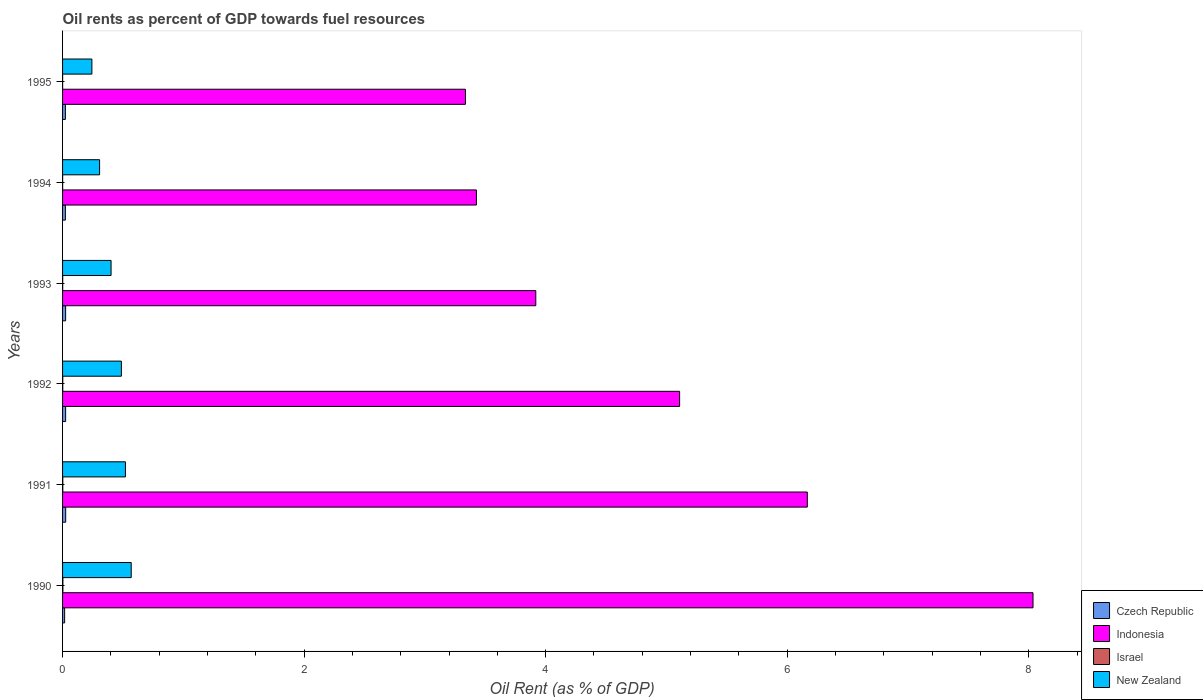How many different coloured bars are there?
Make the answer very short. 4. How many groups of bars are there?
Offer a terse response. 6. Are the number of bars on each tick of the Y-axis equal?
Give a very brief answer. Yes. How many bars are there on the 1st tick from the top?
Ensure brevity in your answer.  4. In how many cases, is the number of bars for a given year not equal to the number of legend labels?
Your response must be concise. 0. What is the oil rent in Czech Republic in 1992?
Offer a terse response. 0.03. Across all years, what is the maximum oil rent in New Zealand?
Offer a very short reply. 0.57. Across all years, what is the minimum oil rent in Indonesia?
Ensure brevity in your answer.  3.34. What is the total oil rent in Czech Republic in the graph?
Your response must be concise. 0.14. What is the difference between the oil rent in New Zealand in 1993 and that in 1994?
Provide a succinct answer. 0.1. What is the difference between the oil rent in Czech Republic in 1994 and the oil rent in Indonesia in 1991?
Your response must be concise. -6.14. What is the average oil rent in Czech Republic per year?
Offer a terse response. 0.02. In the year 1991, what is the difference between the oil rent in New Zealand and oil rent in Czech Republic?
Give a very brief answer. 0.49. What is the ratio of the oil rent in New Zealand in 1994 to that in 1995?
Offer a terse response. 1.26. Is the difference between the oil rent in New Zealand in 1992 and 1995 greater than the difference between the oil rent in Czech Republic in 1992 and 1995?
Keep it short and to the point. Yes. What is the difference between the highest and the second highest oil rent in New Zealand?
Offer a terse response. 0.05. What is the difference between the highest and the lowest oil rent in New Zealand?
Make the answer very short. 0.33. In how many years, is the oil rent in Indonesia greater than the average oil rent in Indonesia taken over all years?
Your answer should be compact. 3. Is it the case that in every year, the sum of the oil rent in New Zealand and oil rent in Czech Republic is greater than the sum of oil rent in Indonesia and oil rent in Israel?
Your response must be concise. Yes. What does the 4th bar from the top in 1994 represents?
Offer a terse response. Czech Republic. What does the 2nd bar from the bottom in 1995 represents?
Ensure brevity in your answer.  Indonesia. Is it the case that in every year, the sum of the oil rent in New Zealand and oil rent in Indonesia is greater than the oil rent in Czech Republic?
Your response must be concise. Yes. Are all the bars in the graph horizontal?
Offer a very short reply. Yes. How many years are there in the graph?
Ensure brevity in your answer.  6. What is the difference between two consecutive major ticks on the X-axis?
Offer a very short reply. 2. Does the graph contain any zero values?
Offer a very short reply. No. Does the graph contain grids?
Provide a short and direct response. No. Where does the legend appear in the graph?
Offer a terse response. Bottom right. How are the legend labels stacked?
Make the answer very short. Vertical. What is the title of the graph?
Keep it short and to the point. Oil rents as percent of GDP towards fuel resources. Does "Congo (Republic)" appear as one of the legend labels in the graph?
Ensure brevity in your answer.  No. What is the label or title of the X-axis?
Your answer should be compact. Oil Rent (as % of GDP). What is the label or title of the Y-axis?
Offer a very short reply. Years. What is the Oil Rent (as % of GDP) of Czech Republic in 1990?
Your response must be concise. 0.02. What is the Oil Rent (as % of GDP) in Indonesia in 1990?
Keep it short and to the point. 8.04. What is the Oil Rent (as % of GDP) of Israel in 1990?
Provide a short and direct response. 0. What is the Oil Rent (as % of GDP) in New Zealand in 1990?
Offer a terse response. 0.57. What is the Oil Rent (as % of GDP) of Czech Republic in 1991?
Your response must be concise. 0.03. What is the Oil Rent (as % of GDP) in Indonesia in 1991?
Give a very brief answer. 6.17. What is the Oil Rent (as % of GDP) in Israel in 1991?
Offer a very short reply. 0. What is the Oil Rent (as % of GDP) of New Zealand in 1991?
Keep it short and to the point. 0.52. What is the Oil Rent (as % of GDP) of Czech Republic in 1992?
Provide a succinct answer. 0.03. What is the Oil Rent (as % of GDP) in Indonesia in 1992?
Offer a very short reply. 5.11. What is the Oil Rent (as % of GDP) of Israel in 1992?
Offer a terse response. 0. What is the Oil Rent (as % of GDP) of New Zealand in 1992?
Provide a short and direct response. 0.49. What is the Oil Rent (as % of GDP) in Czech Republic in 1993?
Make the answer very short. 0.03. What is the Oil Rent (as % of GDP) of Indonesia in 1993?
Your answer should be compact. 3.92. What is the Oil Rent (as % of GDP) of Israel in 1993?
Provide a short and direct response. 0. What is the Oil Rent (as % of GDP) in New Zealand in 1993?
Give a very brief answer. 0.4. What is the Oil Rent (as % of GDP) in Czech Republic in 1994?
Make the answer very short. 0.02. What is the Oil Rent (as % of GDP) of Indonesia in 1994?
Make the answer very short. 3.43. What is the Oil Rent (as % of GDP) of Israel in 1994?
Offer a terse response. 0. What is the Oil Rent (as % of GDP) in New Zealand in 1994?
Offer a terse response. 0.31. What is the Oil Rent (as % of GDP) of Czech Republic in 1995?
Keep it short and to the point. 0.02. What is the Oil Rent (as % of GDP) in Indonesia in 1995?
Your response must be concise. 3.34. What is the Oil Rent (as % of GDP) in Israel in 1995?
Your answer should be compact. 0. What is the Oil Rent (as % of GDP) in New Zealand in 1995?
Your response must be concise. 0.24. Across all years, what is the maximum Oil Rent (as % of GDP) of Czech Republic?
Provide a short and direct response. 0.03. Across all years, what is the maximum Oil Rent (as % of GDP) of Indonesia?
Make the answer very short. 8.04. Across all years, what is the maximum Oil Rent (as % of GDP) in Israel?
Keep it short and to the point. 0. Across all years, what is the maximum Oil Rent (as % of GDP) of New Zealand?
Your answer should be compact. 0.57. Across all years, what is the minimum Oil Rent (as % of GDP) of Czech Republic?
Your answer should be compact. 0.02. Across all years, what is the minimum Oil Rent (as % of GDP) of Indonesia?
Your response must be concise. 3.34. Across all years, what is the minimum Oil Rent (as % of GDP) in Israel?
Your answer should be very brief. 0. Across all years, what is the minimum Oil Rent (as % of GDP) of New Zealand?
Ensure brevity in your answer.  0.24. What is the total Oil Rent (as % of GDP) in Czech Republic in the graph?
Your answer should be very brief. 0.14. What is the total Oil Rent (as % of GDP) of Indonesia in the graph?
Make the answer very short. 29.99. What is the total Oil Rent (as % of GDP) of Israel in the graph?
Give a very brief answer. 0.01. What is the total Oil Rent (as % of GDP) in New Zealand in the graph?
Provide a succinct answer. 2.53. What is the difference between the Oil Rent (as % of GDP) of Czech Republic in 1990 and that in 1991?
Your answer should be very brief. -0.01. What is the difference between the Oil Rent (as % of GDP) of Indonesia in 1990 and that in 1991?
Your answer should be very brief. 1.87. What is the difference between the Oil Rent (as % of GDP) in Israel in 1990 and that in 1991?
Keep it short and to the point. 0. What is the difference between the Oil Rent (as % of GDP) in New Zealand in 1990 and that in 1991?
Give a very brief answer. 0.05. What is the difference between the Oil Rent (as % of GDP) of Czech Republic in 1990 and that in 1992?
Provide a short and direct response. -0.01. What is the difference between the Oil Rent (as % of GDP) of Indonesia in 1990 and that in 1992?
Ensure brevity in your answer.  2.93. What is the difference between the Oil Rent (as % of GDP) of Israel in 1990 and that in 1992?
Provide a short and direct response. 0. What is the difference between the Oil Rent (as % of GDP) in New Zealand in 1990 and that in 1992?
Your response must be concise. 0.08. What is the difference between the Oil Rent (as % of GDP) of Czech Republic in 1990 and that in 1993?
Your response must be concise. -0.01. What is the difference between the Oil Rent (as % of GDP) in Indonesia in 1990 and that in 1993?
Offer a terse response. 4.12. What is the difference between the Oil Rent (as % of GDP) of Israel in 1990 and that in 1993?
Offer a terse response. 0. What is the difference between the Oil Rent (as % of GDP) of New Zealand in 1990 and that in 1993?
Ensure brevity in your answer.  0.17. What is the difference between the Oil Rent (as % of GDP) of Czech Republic in 1990 and that in 1994?
Provide a short and direct response. -0.01. What is the difference between the Oil Rent (as % of GDP) in Indonesia in 1990 and that in 1994?
Offer a very short reply. 4.61. What is the difference between the Oil Rent (as % of GDP) of Israel in 1990 and that in 1994?
Give a very brief answer. 0. What is the difference between the Oil Rent (as % of GDP) of New Zealand in 1990 and that in 1994?
Provide a short and direct response. 0.26. What is the difference between the Oil Rent (as % of GDP) in Czech Republic in 1990 and that in 1995?
Make the answer very short. -0.01. What is the difference between the Oil Rent (as % of GDP) in Indonesia in 1990 and that in 1995?
Make the answer very short. 4.7. What is the difference between the Oil Rent (as % of GDP) of Israel in 1990 and that in 1995?
Offer a terse response. 0. What is the difference between the Oil Rent (as % of GDP) of New Zealand in 1990 and that in 1995?
Make the answer very short. 0.33. What is the difference between the Oil Rent (as % of GDP) in Indonesia in 1991 and that in 1992?
Your response must be concise. 1.06. What is the difference between the Oil Rent (as % of GDP) of New Zealand in 1991 and that in 1992?
Provide a succinct answer. 0.03. What is the difference between the Oil Rent (as % of GDP) in Indonesia in 1991 and that in 1993?
Make the answer very short. 2.25. What is the difference between the Oil Rent (as % of GDP) in Israel in 1991 and that in 1993?
Give a very brief answer. 0. What is the difference between the Oil Rent (as % of GDP) of New Zealand in 1991 and that in 1993?
Keep it short and to the point. 0.12. What is the difference between the Oil Rent (as % of GDP) of Czech Republic in 1991 and that in 1994?
Make the answer very short. 0. What is the difference between the Oil Rent (as % of GDP) in Indonesia in 1991 and that in 1994?
Your answer should be compact. 2.74. What is the difference between the Oil Rent (as % of GDP) of Israel in 1991 and that in 1994?
Your answer should be very brief. 0. What is the difference between the Oil Rent (as % of GDP) of New Zealand in 1991 and that in 1994?
Provide a succinct answer. 0.21. What is the difference between the Oil Rent (as % of GDP) in Czech Republic in 1991 and that in 1995?
Your answer should be very brief. 0. What is the difference between the Oil Rent (as % of GDP) of Indonesia in 1991 and that in 1995?
Offer a very short reply. 2.83. What is the difference between the Oil Rent (as % of GDP) of Israel in 1991 and that in 1995?
Offer a terse response. 0. What is the difference between the Oil Rent (as % of GDP) of New Zealand in 1991 and that in 1995?
Give a very brief answer. 0.28. What is the difference between the Oil Rent (as % of GDP) in Czech Republic in 1992 and that in 1993?
Provide a succinct answer. -0. What is the difference between the Oil Rent (as % of GDP) in Indonesia in 1992 and that in 1993?
Ensure brevity in your answer.  1.19. What is the difference between the Oil Rent (as % of GDP) of Israel in 1992 and that in 1993?
Your answer should be very brief. 0. What is the difference between the Oil Rent (as % of GDP) of New Zealand in 1992 and that in 1993?
Offer a terse response. 0.09. What is the difference between the Oil Rent (as % of GDP) in Czech Republic in 1992 and that in 1994?
Your answer should be compact. 0. What is the difference between the Oil Rent (as % of GDP) of Indonesia in 1992 and that in 1994?
Give a very brief answer. 1.68. What is the difference between the Oil Rent (as % of GDP) of New Zealand in 1992 and that in 1994?
Provide a short and direct response. 0.18. What is the difference between the Oil Rent (as % of GDP) of Czech Republic in 1992 and that in 1995?
Ensure brevity in your answer.  0. What is the difference between the Oil Rent (as % of GDP) of Indonesia in 1992 and that in 1995?
Ensure brevity in your answer.  1.77. What is the difference between the Oil Rent (as % of GDP) in Israel in 1992 and that in 1995?
Make the answer very short. 0. What is the difference between the Oil Rent (as % of GDP) in New Zealand in 1992 and that in 1995?
Ensure brevity in your answer.  0.24. What is the difference between the Oil Rent (as % of GDP) of Czech Republic in 1993 and that in 1994?
Provide a short and direct response. 0. What is the difference between the Oil Rent (as % of GDP) of Indonesia in 1993 and that in 1994?
Ensure brevity in your answer.  0.49. What is the difference between the Oil Rent (as % of GDP) of New Zealand in 1993 and that in 1994?
Give a very brief answer. 0.1. What is the difference between the Oil Rent (as % of GDP) in Czech Republic in 1993 and that in 1995?
Your answer should be compact. 0. What is the difference between the Oil Rent (as % of GDP) of Indonesia in 1993 and that in 1995?
Offer a terse response. 0.58. What is the difference between the Oil Rent (as % of GDP) in Israel in 1993 and that in 1995?
Make the answer very short. 0. What is the difference between the Oil Rent (as % of GDP) in New Zealand in 1993 and that in 1995?
Make the answer very short. 0.16. What is the difference between the Oil Rent (as % of GDP) of Czech Republic in 1994 and that in 1995?
Keep it short and to the point. -0. What is the difference between the Oil Rent (as % of GDP) of Indonesia in 1994 and that in 1995?
Provide a succinct answer. 0.09. What is the difference between the Oil Rent (as % of GDP) of New Zealand in 1994 and that in 1995?
Your answer should be compact. 0.06. What is the difference between the Oil Rent (as % of GDP) of Czech Republic in 1990 and the Oil Rent (as % of GDP) of Indonesia in 1991?
Make the answer very short. -6.15. What is the difference between the Oil Rent (as % of GDP) in Czech Republic in 1990 and the Oil Rent (as % of GDP) in Israel in 1991?
Offer a very short reply. 0.02. What is the difference between the Oil Rent (as % of GDP) of Czech Republic in 1990 and the Oil Rent (as % of GDP) of New Zealand in 1991?
Your answer should be very brief. -0.5. What is the difference between the Oil Rent (as % of GDP) in Indonesia in 1990 and the Oil Rent (as % of GDP) in Israel in 1991?
Your response must be concise. 8.03. What is the difference between the Oil Rent (as % of GDP) of Indonesia in 1990 and the Oil Rent (as % of GDP) of New Zealand in 1991?
Your answer should be compact. 7.51. What is the difference between the Oil Rent (as % of GDP) in Israel in 1990 and the Oil Rent (as % of GDP) in New Zealand in 1991?
Give a very brief answer. -0.52. What is the difference between the Oil Rent (as % of GDP) of Czech Republic in 1990 and the Oil Rent (as % of GDP) of Indonesia in 1992?
Give a very brief answer. -5.09. What is the difference between the Oil Rent (as % of GDP) in Czech Republic in 1990 and the Oil Rent (as % of GDP) in Israel in 1992?
Offer a very short reply. 0.02. What is the difference between the Oil Rent (as % of GDP) in Czech Republic in 1990 and the Oil Rent (as % of GDP) in New Zealand in 1992?
Provide a succinct answer. -0.47. What is the difference between the Oil Rent (as % of GDP) in Indonesia in 1990 and the Oil Rent (as % of GDP) in Israel in 1992?
Offer a terse response. 8.03. What is the difference between the Oil Rent (as % of GDP) of Indonesia in 1990 and the Oil Rent (as % of GDP) of New Zealand in 1992?
Ensure brevity in your answer.  7.55. What is the difference between the Oil Rent (as % of GDP) in Israel in 1990 and the Oil Rent (as % of GDP) in New Zealand in 1992?
Your answer should be very brief. -0.48. What is the difference between the Oil Rent (as % of GDP) of Czech Republic in 1990 and the Oil Rent (as % of GDP) of Indonesia in 1993?
Keep it short and to the point. -3.9. What is the difference between the Oil Rent (as % of GDP) of Czech Republic in 1990 and the Oil Rent (as % of GDP) of Israel in 1993?
Ensure brevity in your answer.  0.02. What is the difference between the Oil Rent (as % of GDP) of Czech Republic in 1990 and the Oil Rent (as % of GDP) of New Zealand in 1993?
Provide a succinct answer. -0.38. What is the difference between the Oil Rent (as % of GDP) in Indonesia in 1990 and the Oil Rent (as % of GDP) in Israel in 1993?
Offer a very short reply. 8.03. What is the difference between the Oil Rent (as % of GDP) of Indonesia in 1990 and the Oil Rent (as % of GDP) of New Zealand in 1993?
Your answer should be compact. 7.63. What is the difference between the Oil Rent (as % of GDP) in Israel in 1990 and the Oil Rent (as % of GDP) in New Zealand in 1993?
Keep it short and to the point. -0.4. What is the difference between the Oil Rent (as % of GDP) of Czech Republic in 1990 and the Oil Rent (as % of GDP) of Indonesia in 1994?
Make the answer very short. -3.41. What is the difference between the Oil Rent (as % of GDP) in Czech Republic in 1990 and the Oil Rent (as % of GDP) in Israel in 1994?
Provide a succinct answer. 0.02. What is the difference between the Oil Rent (as % of GDP) in Czech Republic in 1990 and the Oil Rent (as % of GDP) in New Zealand in 1994?
Make the answer very short. -0.29. What is the difference between the Oil Rent (as % of GDP) of Indonesia in 1990 and the Oil Rent (as % of GDP) of Israel in 1994?
Provide a short and direct response. 8.04. What is the difference between the Oil Rent (as % of GDP) in Indonesia in 1990 and the Oil Rent (as % of GDP) in New Zealand in 1994?
Offer a terse response. 7.73. What is the difference between the Oil Rent (as % of GDP) in Israel in 1990 and the Oil Rent (as % of GDP) in New Zealand in 1994?
Your answer should be very brief. -0.3. What is the difference between the Oil Rent (as % of GDP) of Czech Republic in 1990 and the Oil Rent (as % of GDP) of Indonesia in 1995?
Make the answer very short. -3.32. What is the difference between the Oil Rent (as % of GDP) of Czech Republic in 1990 and the Oil Rent (as % of GDP) of Israel in 1995?
Offer a terse response. 0.02. What is the difference between the Oil Rent (as % of GDP) of Czech Republic in 1990 and the Oil Rent (as % of GDP) of New Zealand in 1995?
Make the answer very short. -0.23. What is the difference between the Oil Rent (as % of GDP) in Indonesia in 1990 and the Oil Rent (as % of GDP) in Israel in 1995?
Keep it short and to the point. 8.04. What is the difference between the Oil Rent (as % of GDP) in Indonesia in 1990 and the Oil Rent (as % of GDP) in New Zealand in 1995?
Your answer should be compact. 7.79. What is the difference between the Oil Rent (as % of GDP) in Israel in 1990 and the Oil Rent (as % of GDP) in New Zealand in 1995?
Make the answer very short. -0.24. What is the difference between the Oil Rent (as % of GDP) of Czech Republic in 1991 and the Oil Rent (as % of GDP) of Indonesia in 1992?
Your answer should be compact. -5.08. What is the difference between the Oil Rent (as % of GDP) of Czech Republic in 1991 and the Oil Rent (as % of GDP) of Israel in 1992?
Your response must be concise. 0.02. What is the difference between the Oil Rent (as % of GDP) of Czech Republic in 1991 and the Oil Rent (as % of GDP) of New Zealand in 1992?
Your response must be concise. -0.46. What is the difference between the Oil Rent (as % of GDP) in Indonesia in 1991 and the Oil Rent (as % of GDP) in Israel in 1992?
Keep it short and to the point. 6.17. What is the difference between the Oil Rent (as % of GDP) in Indonesia in 1991 and the Oil Rent (as % of GDP) in New Zealand in 1992?
Make the answer very short. 5.68. What is the difference between the Oil Rent (as % of GDP) of Israel in 1991 and the Oil Rent (as % of GDP) of New Zealand in 1992?
Provide a short and direct response. -0.49. What is the difference between the Oil Rent (as % of GDP) of Czech Republic in 1991 and the Oil Rent (as % of GDP) of Indonesia in 1993?
Make the answer very short. -3.89. What is the difference between the Oil Rent (as % of GDP) of Czech Republic in 1991 and the Oil Rent (as % of GDP) of Israel in 1993?
Your answer should be compact. 0.02. What is the difference between the Oil Rent (as % of GDP) in Czech Republic in 1991 and the Oil Rent (as % of GDP) in New Zealand in 1993?
Offer a terse response. -0.38. What is the difference between the Oil Rent (as % of GDP) of Indonesia in 1991 and the Oil Rent (as % of GDP) of Israel in 1993?
Provide a short and direct response. 6.17. What is the difference between the Oil Rent (as % of GDP) of Indonesia in 1991 and the Oil Rent (as % of GDP) of New Zealand in 1993?
Ensure brevity in your answer.  5.77. What is the difference between the Oil Rent (as % of GDP) of Israel in 1991 and the Oil Rent (as % of GDP) of New Zealand in 1993?
Your answer should be very brief. -0.4. What is the difference between the Oil Rent (as % of GDP) of Czech Republic in 1991 and the Oil Rent (as % of GDP) of Indonesia in 1994?
Make the answer very short. -3.4. What is the difference between the Oil Rent (as % of GDP) in Czech Republic in 1991 and the Oil Rent (as % of GDP) in Israel in 1994?
Provide a succinct answer. 0.03. What is the difference between the Oil Rent (as % of GDP) in Czech Republic in 1991 and the Oil Rent (as % of GDP) in New Zealand in 1994?
Make the answer very short. -0.28. What is the difference between the Oil Rent (as % of GDP) in Indonesia in 1991 and the Oil Rent (as % of GDP) in Israel in 1994?
Give a very brief answer. 6.17. What is the difference between the Oil Rent (as % of GDP) of Indonesia in 1991 and the Oil Rent (as % of GDP) of New Zealand in 1994?
Keep it short and to the point. 5.86. What is the difference between the Oil Rent (as % of GDP) of Israel in 1991 and the Oil Rent (as % of GDP) of New Zealand in 1994?
Ensure brevity in your answer.  -0.3. What is the difference between the Oil Rent (as % of GDP) of Czech Republic in 1991 and the Oil Rent (as % of GDP) of Indonesia in 1995?
Offer a very short reply. -3.31. What is the difference between the Oil Rent (as % of GDP) in Czech Republic in 1991 and the Oil Rent (as % of GDP) in Israel in 1995?
Offer a terse response. 0.03. What is the difference between the Oil Rent (as % of GDP) in Czech Republic in 1991 and the Oil Rent (as % of GDP) in New Zealand in 1995?
Your answer should be compact. -0.22. What is the difference between the Oil Rent (as % of GDP) of Indonesia in 1991 and the Oil Rent (as % of GDP) of Israel in 1995?
Ensure brevity in your answer.  6.17. What is the difference between the Oil Rent (as % of GDP) of Indonesia in 1991 and the Oil Rent (as % of GDP) of New Zealand in 1995?
Ensure brevity in your answer.  5.92. What is the difference between the Oil Rent (as % of GDP) of Israel in 1991 and the Oil Rent (as % of GDP) of New Zealand in 1995?
Offer a terse response. -0.24. What is the difference between the Oil Rent (as % of GDP) of Czech Republic in 1992 and the Oil Rent (as % of GDP) of Indonesia in 1993?
Ensure brevity in your answer.  -3.89. What is the difference between the Oil Rent (as % of GDP) in Czech Republic in 1992 and the Oil Rent (as % of GDP) in Israel in 1993?
Provide a succinct answer. 0.02. What is the difference between the Oil Rent (as % of GDP) of Czech Republic in 1992 and the Oil Rent (as % of GDP) of New Zealand in 1993?
Offer a very short reply. -0.38. What is the difference between the Oil Rent (as % of GDP) in Indonesia in 1992 and the Oil Rent (as % of GDP) in Israel in 1993?
Your answer should be very brief. 5.11. What is the difference between the Oil Rent (as % of GDP) in Indonesia in 1992 and the Oil Rent (as % of GDP) in New Zealand in 1993?
Offer a terse response. 4.71. What is the difference between the Oil Rent (as % of GDP) of Israel in 1992 and the Oil Rent (as % of GDP) of New Zealand in 1993?
Offer a terse response. -0.4. What is the difference between the Oil Rent (as % of GDP) in Czech Republic in 1992 and the Oil Rent (as % of GDP) in Indonesia in 1994?
Keep it short and to the point. -3.4. What is the difference between the Oil Rent (as % of GDP) in Czech Republic in 1992 and the Oil Rent (as % of GDP) in Israel in 1994?
Make the answer very short. 0.02. What is the difference between the Oil Rent (as % of GDP) in Czech Republic in 1992 and the Oil Rent (as % of GDP) in New Zealand in 1994?
Provide a succinct answer. -0.28. What is the difference between the Oil Rent (as % of GDP) in Indonesia in 1992 and the Oil Rent (as % of GDP) in Israel in 1994?
Your answer should be very brief. 5.11. What is the difference between the Oil Rent (as % of GDP) of Indonesia in 1992 and the Oil Rent (as % of GDP) of New Zealand in 1994?
Ensure brevity in your answer.  4.8. What is the difference between the Oil Rent (as % of GDP) in Israel in 1992 and the Oil Rent (as % of GDP) in New Zealand in 1994?
Provide a short and direct response. -0.3. What is the difference between the Oil Rent (as % of GDP) of Czech Republic in 1992 and the Oil Rent (as % of GDP) of Indonesia in 1995?
Make the answer very short. -3.31. What is the difference between the Oil Rent (as % of GDP) in Czech Republic in 1992 and the Oil Rent (as % of GDP) in Israel in 1995?
Your response must be concise. 0.02. What is the difference between the Oil Rent (as % of GDP) of Czech Republic in 1992 and the Oil Rent (as % of GDP) of New Zealand in 1995?
Your answer should be compact. -0.22. What is the difference between the Oil Rent (as % of GDP) in Indonesia in 1992 and the Oil Rent (as % of GDP) in Israel in 1995?
Provide a short and direct response. 5.11. What is the difference between the Oil Rent (as % of GDP) of Indonesia in 1992 and the Oil Rent (as % of GDP) of New Zealand in 1995?
Provide a succinct answer. 4.87. What is the difference between the Oil Rent (as % of GDP) of Israel in 1992 and the Oil Rent (as % of GDP) of New Zealand in 1995?
Provide a succinct answer. -0.24. What is the difference between the Oil Rent (as % of GDP) in Czech Republic in 1993 and the Oil Rent (as % of GDP) in Indonesia in 1994?
Your response must be concise. -3.4. What is the difference between the Oil Rent (as % of GDP) of Czech Republic in 1993 and the Oil Rent (as % of GDP) of Israel in 1994?
Keep it short and to the point. 0.02. What is the difference between the Oil Rent (as % of GDP) of Czech Republic in 1993 and the Oil Rent (as % of GDP) of New Zealand in 1994?
Your answer should be very brief. -0.28. What is the difference between the Oil Rent (as % of GDP) of Indonesia in 1993 and the Oil Rent (as % of GDP) of Israel in 1994?
Offer a terse response. 3.92. What is the difference between the Oil Rent (as % of GDP) in Indonesia in 1993 and the Oil Rent (as % of GDP) in New Zealand in 1994?
Your response must be concise. 3.61. What is the difference between the Oil Rent (as % of GDP) of Israel in 1993 and the Oil Rent (as % of GDP) of New Zealand in 1994?
Provide a short and direct response. -0.31. What is the difference between the Oil Rent (as % of GDP) of Czech Republic in 1993 and the Oil Rent (as % of GDP) of Indonesia in 1995?
Make the answer very short. -3.31. What is the difference between the Oil Rent (as % of GDP) in Czech Republic in 1993 and the Oil Rent (as % of GDP) in Israel in 1995?
Your response must be concise. 0.02. What is the difference between the Oil Rent (as % of GDP) of Czech Republic in 1993 and the Oil Rent (as % of GDP) of New Zealand in 1995?
Offer a terse response. -0.22. What is the difference between the Oil Rent (as % of GDP) in Indonesia in 1993 and the Oil Rent (as % of GDP) in Israel in 1995?
Offer a very short reply. 3.92. What is the difference between the Oil Rent (as % of GDP) of Indonesia in 1993 and the Oil Rent (as % of GDP) of New Zealand in 1995?
Offer a terse response. 3.68. What is the difference between the Oil Rent (as % of GDP) in Israel in 1993 and the Oil Rent (as % of GDP) in New Zealand in 1995?
Offer a terse response. -0.24. What is the difference between the Oil Rent (as % of GDP) of Czech Republic in 1994 and the Oil Rent (as % of GDP) of Indonesia in 1995?
Offer a terse response. -3.31. What is the difference between the Oil Rent (as % of GDP) of Czech Republic in 1994 and the Oil Rent (as % of GDP) of Israel in 1995?
Your response must be concise. 0.02. What is the difference between the Oil Rent (as % of GDP) in Czech Republic in 1994 and the Oil Rent (as % of GDP) in New Zealand in 1995?
Ensure brevity in your answer.  -0.22. What is the difference between the Oil Rent (as % of GDP) of Indonesia in 1994 and the Oil Rent (as % of GDP) of Israel in 1995?
Provide a succinct answer. 3.43. What is the difference between the Oil Rent (as % of GDP) of Indonesia in 1994 and the Oil Rent (as % of GDP) of New Zealand in 1995?
Your answer should be compact. 3.18. What is the difference between the Oil Rent (as % of GDP) in Israel in 1994 and the Oil Rent (as % of GDP) in New Zealand in 1995?
Your answer should be compact. -0.24. What is the average Oil Rent (as % of GDP) of Czech Republic per year?
Offer a very short reply. 0.02. What is the average Oil Rent (as % of GDP) of Indonesia per year?
Provide a short and direct response. 5. What is the average Oil Rent (as % of GDP) of Israel per year?
Make the answer very short. 0. What is the average Oil Rent (as % of GDP) in New Zealand per year?
Your answer should be very brief. 0.42. In the year 1990, what is the difference between the Oil Rent (as % of GDP) in Czech Republic and Oil Rent (as % of GDP) in Indonesia?
Offer a terse response. -8.02. In the year 1990, what is the difference between the Oil Rent (as % of GDP) of Czech Republic and Oil Rent (as % of GDP) of Israel?
Give a very brief answer. 0.01. In the year 1990, what is the difference between the Oil Rent (as % of GDP) of Czech Republic and Oil Rent (as % of GDP) of New Zealand?
Make the answer very short. -0.55. In the year 1990, what is the difference between the Oil Rent (as % of GDP) of Indonesia and Oil Rent (as % of GDP) of Israel?
Keep it short and to the point. 8.03. In the year 1990, what is the difference between the Oil Rent (as % of GDP) of Indonesia and Oil Rent (as % of GDP) of New Zealand?
Keep it short and to the point. 7.47. In the year 1990, what is the difference between the Oil Rent (as % of GDP) of Israel and Oil Rent (as % of GDP) of New Zealand?
Provide a succinct answer. -0.57. In the year 1991, what is the difference between the Oil Rent (as % of GDP) in Czech Republic and Oil Rent (as % of GDP) in Indonesia?
Your response must be concise. -6.14. In the year 1991, what is the difference between the Oil Rent (as % of GDP) in Czech Republic and Oil Rent (as % of GDP) in Israel?
Ensure brevity in your answer.  0.02. In the year 1991, what is the difference between the Oil Rent (as % of GDP) of Czech Republic and Oil Rent (as % of GDP) of New Zealand?
Provide a succinct answer. -0.49. In the year 1991, what is the difference between the Oil Rent (as % of GDP) of Indonesia and Oil Rent (as % of GDP) of Israel?
Make the answer very short. 6.16. In the year 1991, what is the difference between the Oil Rent (as % of GDP) in Indonesia and Oil Rent (as % of GDP) in New Zealand?
Give a very brief answer. 5.65. In the year 1991, what is the difference between the Oil Rent (as % of GDP) of Israel and Oil Rent (as % of GDP) of New Zealand?
Your response must be concise. -0.52. In the year 1992, what is the difference between the Oil Rent (as % of GDP) in Czech Republic and Oil Rent (as % of GDP) in Indonesia?
Give a very brief answer. -5.08. In the year 1992, what is the difference between the Oil Rent (as % of GDP) in Czech Republic and Oil Rent (as % of GDP) in Israel?
Provide a succinct answer. 0.02. In the year 1992, what is the difference between the Oil Rent (as % of GDP) in Czech Republic and Oil Rent (as % of GDP) in New Zealand?
Provide a short and direct response. -0.46. In the year 1992, what is the difference between the Oil Rent (as % of GDP) of Indonesia and Oil Rent (as % of GDP) of Israel?
Your response must be concise. 5.11. In the year 1992, what is the difference between the Oil Rent (as % of GDP) of Indonesia and Oil Rent (as % of GDP) of New Zealand?
Ensure brevity in your answer.  4.62. In the year 1992, what is the difference between the Oil Rent (as % of GDP) of Israel and Oil Rent (as % of GDP) of New Zealand?
Make the answer very short. -0.49. In the year 1993, what is the difference between the Oil Rent (as % of GDP) of Czech Republic and Oil Rent (as % of GDP) of Indonesia?
Ensure brevity in your answer.  -3.89. In the year 1993, what is the difference between the Oil Rent (as % of GDP) in Czech Republic and Oil Rent (as % of GDP) in Israel?
Provide a short and direct response. 0.02. In the year 1993, what is the difference between the Oil Rent (as % of GDP) of Czech Republic and Oil Rent (as % of GDP) of New Zealand?
Your response must be concise. -0.38. In the year 1993, what is the difference between the Oil Rent (as % of GDP) in Indonesia and Oil Rent (as % of GDP) in Israel?
Offer a very short reply. 3.92. In the year 1993, what is the difference between the Oil Rent (as % of GDP) of Indonesia and Oil Rent (as % of GDP) of New Zealand?
Offer a terse response. 3.52. In the year 1993, what is the difference between the Oil Rent (as % of GDP) of Israel and Oil Rent (as % of GDP) of New Zealand?
Offer a terse response. -0.4. In the year 1994, what is the difference between the Oil Rent (as % of GDP) in Czech Republic and Oil Rent (as % of GDP) in Indonesia?
Make the answer very short. -3.4. In the year 1994, what is the difference between the Oil Rent (as % of GDP) of Czech Republic and Oil Rent (as % of GDP) of Israel?
Your response must be concise. 0.02. In the year 1994, what is the difference between the Oil Rent (as % of GDP) of Czech Republic and Oil Rent (as % of GDP) of New Zealand?
Your answer should be compact. -0.28. In the year 1994, what is the difference between the Oil Rent (as % of GDP) in Indonesia and Oil Rent (as % of GDP) in Israel?
Provide a succinct answer. 3.43. In the year 1994, what is the difference between the Oil Rent (as % of GDP) in Indonesia and Oil Rent (as % of GDP) in New Zealand?
Offer a very short reply. 3.12. In the year 1994, what is the difference between the Oil Rent (as % of GDP) of Israel and Oil Rent (as % of GDP) of New Zealand?
Your response must be concise. -0.31. In the year 1995, what is the difference between the Oil Rent (as % of GDP) in Czech Republic and Oil Rent (as % of GDP) in Indonesia?
Offer a terse response. -3.31. In the year 1995, what is the difference between the Oil Rent (as % of GDP) in Czech Republic and Oil Rent (as % of GDP) in Israel?
Provide a short and direct response. 0.02. In the year 1995, what is the difference between the Oil Rent (as % of GDP) of Czech Republic and Oil Rent (as % of GDP) of New Zealand?
Your answer should be compact. -0.22. In the year 1995, what is the difference between the Oil Rent (as % of GDP) in Indonesia and Oil Rent (as % of GDP) in Israel?
Offer a terse response. 3.34. In the year 1995, what is the difference between the Oil Rent (as % of GDP) in Indonesia and Oil Rent (as % of GDP) in New Zealand?
Offer a terse response. 3.09. In the year 1995, what is the difference between the Oil Rent (as % of GDP) in Israel and Oil Rent (as % of GDP) in New Zealand?
Give a very brief answer. -0.24. What is the ratio of the Oil Rent (as % of GDP) of Czech Republic in 1990 to that in 1991?
Ensure brevity in your answer.  0.66. What is the ratio of the Oil Rent (as % of GDP) in Indonesia in 1990 to that in 1991?
Your answer should be compact. 1.3. What is the ratio of the Oil Rent (as % of GDP) of Israel in 1990 to that in 1991?
Offer a terse response. 1.38. What is the ratio of the Oil Rent (as % of GDP) of New Zealand in 1990 to that in 1991?
Make the answer very short. 1.09. What is the ratio of the Oil Rent (as % of GDP) of Czech Republic in 1990 to that in 1992?
Offer a very short reply. 0.67. What is the ratio of the Oil Rent (as % of GDP) in Indonesia in 1990 to that in 1992?
Offer a terse response. 1.57. What is the ratio of the Oil Rent (as % of GDP) in Israel in 1990 to that in 1992?
Offer a terse response. 1.7. What is the ratio of the Oil Rent (as % of GDP) of New Zealand in 1990 to that in 1992?
Your answer should be very brief. 1.17. What is the ratio of the Oil Rent (as % of GDP) in Czech Republic in 1990 to that in 1993?
Provide a short and direct response. 0.67. What is the ratio of the Oil Rent (as % of GDP) in Indonesia in 1990 to that in 1993?
Give a very brief answer. 2.05. What is the ratio of the Oil Rent (as % of GDP) in Israel in 1990 to that in 1993?
Provide a succinct answer. 2.38. What is the ratio of the Oil Rent (as % of GDP) of New Zealand in 1990 to that in 1993?
Keep it short and to the point. 1.42. What is the ratio of the Oil Rent (as % of GDP) of Czech Republic in 1990 to that in 1994?
Provide a succinct answer. 0.73. What is the ratio of the Oil Rent (as % of GDP) of Indonesia in 1990 to that in 1994?
Your response must be concise. 2.34. What is the ratio of the Oil Rent (as % of GDP) in Israel in 1990 to that in 1994?
Give a very brief answer. 4.41. What is the ratio of the Oil Rent (as % of GDP) of New Zealand in 1990 to that in 1994?
Provide a short and direct response. 1.85. What is the ratio of the Oil Rent (as % of GDP) in Czech Republic in 1990 to that in 1995?
Offer a very short reply. 0.73. What is the ratio of the Oil Rent (as % of GDP) of Indonesia in 1990 to that in 1995?
Offer a very short reply. 2.41. What is the ratio of the Oil Rent (as % of GDP) in Israel in 1990 to that in 1995?
Ensure brevity in your answer.  5.34. What is the ratio of the Oil Rent (as % of GDP) in New Zealand in 1990 to that in 1995?
Provide a short and direct response. 2.34. What is the ratio of the Oil Rent (as % of GDP) of Czech Republic in 1991 to that in 1992?
Your response must be concise. 1.02. What is the ratio of the Oil Rent (as % of GDP) of Indonesia in 1991 to that in 1992?
Your answer should be compact. 1.21. What is the ratio of the Oil Rent (as % of GDP) in Israel in 1991 to that in 1992?
Offer a very short reply. 1.23. What is the ratio of the Oil Rent (as % of GDP) in New Zealand in 1991 to that in 1992?
Give a very brief answer. 1.07. What is the ratio of the Oil Rent (as % of GDP) of Czech Republic in 1991 to that in 1993?
Your answer should be very brief. 1.02. What is the ratio of the Oil Rent (as % of GDP) in Indonesia in 1991 to that in 1993?
Provide a short and direct response. 1.57. What is the ratio of the Oil Rent (as % of GDP) in Israel in 1991 to that in 1993?
Keep it short and to the point. 1.73. What is the ratio of the Oil Rent (as % of GDP) in New Zealand in 1991 to that in 1993?
Your answer should be very brief. 1.3. What is the ratio of the Oil Rent (as % of GDP) of Czech Republic in 1991 to that in 1994?
Provide a succinct answer. 1.11. What is the ratio of the Oil Rent (as % of GDP) of Indonesia in 1991 to that in 1994?
Make the answer very short. 1.8. What is the ratio of the Oil Rent (as % of GDP) in Israel in 1991 to that in 1994?
Your response must be concise. 3.2. What is the ratio of the Oil Rent (as % of GDP) of New Zealand in 1991 to that in 1994?
Keep it short and to the point. 1.7. What is the ratio of the Oil Rent (as % of GDP) of Czech Republic in 1991 to that in 1995?
Give a very brief answer. 1.11. What is the ratio of the Oil Rent (as % of GDP) of Indonesia in 1991 to that in 1995?
Your answer should be very brief. 1.85. What is the ratio of the Oil Rent (as % of GDP) in Israel in 1991 to that in 1995?
Make the answer very short. 3.87. What is the ratio of the Oil Rent (as % of GDP) of New Zealand in 1991 to that in 1995?
Your answer should be compact. 2.14. What is the ratio of the Oil Rent (as % of GDP) of Indonesia in 1992 to that in 1993?
Provide a succinct answer. 1.3. What is the ratio of the Oil Rent (as % of GDP) of Israel in 1992 to that in 1993?
Ensure brevity in your answer.  1.4. What is the ratio of the Oil Rent (as % of GDP) in New Zealand in 1992 to that in 1993?
Your response must be concise. 1.21. What is the ratio of the Oil Rent (as % of GDP) of Czech Republic in 1992 to that in 1994?
Provide a succinct answer. 1.09. What is the ratio of the Oil Rent (as % of GDP) in Indonesia in 1992 to that in 1994?
Keep it short and to the point. 1.49. What is the ratio of the Oil Rent (as % of GDP) in Israel in 1992 to that in 1994?
Ensure brevity in your answer.  2.59. What is the ratio of the Oil Rent (as % of GDP) in New Zealand in 1992 to that in 1994?
Your answer should be compact. 1.59. What is the ratio of the Oil Rent (as % of GDP) of Czech Republic in 1992 to that in 1995?
Offer a terse response. 1.08. What is the ratio of the Oil Rent (as % of GDP) of Indonesia in 1992 to that in 1995?
Provide a short and direct response. 1.53. What is the ratio of the Oil Rent (as % of GDP) of Israel in 1992 to that in 1995?
Offer a very short reply. 3.14. What is the ratio of the Oil Rent (as % of GDP) of New Zealand in 1992 to that in 1995?
Provide a short and direct response. 2.01. What is the ratio of the Oil Rent (as % of GDP) in Czech Republic in 1993 to that in 1994?
Your answer should be compact. 1.09. What is the ratio of the Oil Rent (as % of GDP) in Indonesia in 1993 to that in 1994?
Provide a short and direct response. 1.14. What is the ratio of the Oil Rent (as % of GDP) in Israel in 1993 to that in 1994?
Give a very brief answer. 1.85. What is the ratio of the Oil Rent (as % of GDP) of New Zealand in 1993 to that in 1994?
Your response must be concise. 1.31. What is the ratio of the Oil Rent (as % of GDP) in Czech Republic in 1993 to that in 1995?
Your answer should be very brief. 1.08. What is the ratio of the Oil Rent (as % of GDP) of Indonesia in 1993 to that in 1995?
Your response must be concise. 1.17. What is the ratio of the Oil Rent (as % of GDP) in Israel in 1993 to that in 1995?
Your answer should be very brief. 2.24. What is the ratio of the Oil Rent (as % of GDP) of New Zealand in 1993 to that in 1995?
Offer a very short reply. 1.65. What is the ratio of the Oil Rent (as % of GDP) in Czech Republic in 1994 to that in 1995?
Your response must be concise. 1. What is the ratio of the Oil Rent (as % of GDP) of Indonesia in 1994 to that in 1995?
Keep it short and to the point. 1.03. What is the ratio of the Oil Rent (as % of GDP) in Israel in 1994 to that in 1995?
Offer a very short reply. 1.21. What is the ratio of the Oil Rent (as % of GDP) of New Zealand in 1994 to that in 1995?
Your response must be concise. 1.26. What is the difference between the highest and the second highest Oil Rent (as % of GDP) in Czech Republic?
Ensure brevity in your answer.  0. What is the difference between the highest and the second highest Oil Rent (as % of GDP) of Indonesia?
Make the answer very short. 1.87. What is the difference between the highest and the second highest Oil Rent (as % of GDP) of Israel?
Offer a terse response. 0. What is the difference between the highest and the second highest Oil Rent (as % of GDP) of New Zealand?
Give a very brief answer. 0.05. What is the difference between the highest and the lowest Oil Rent (as % of GDP) of Czech Republic?
Make the answer very short. 0.01. What is the difference between the highest and the lowest Oil Rent (as % of GDP) in Indonesia?
Your answer should be very brief. 4.7. What is the difference between the highest and the lowest Oil Rent (as % of GDP) in Israel?
Provide a succinct answer. 0. What is the difference between the highest and the lowest Oil Rent (as % of GDP) of New Zealand?
Offer a terse response. 0.33. 